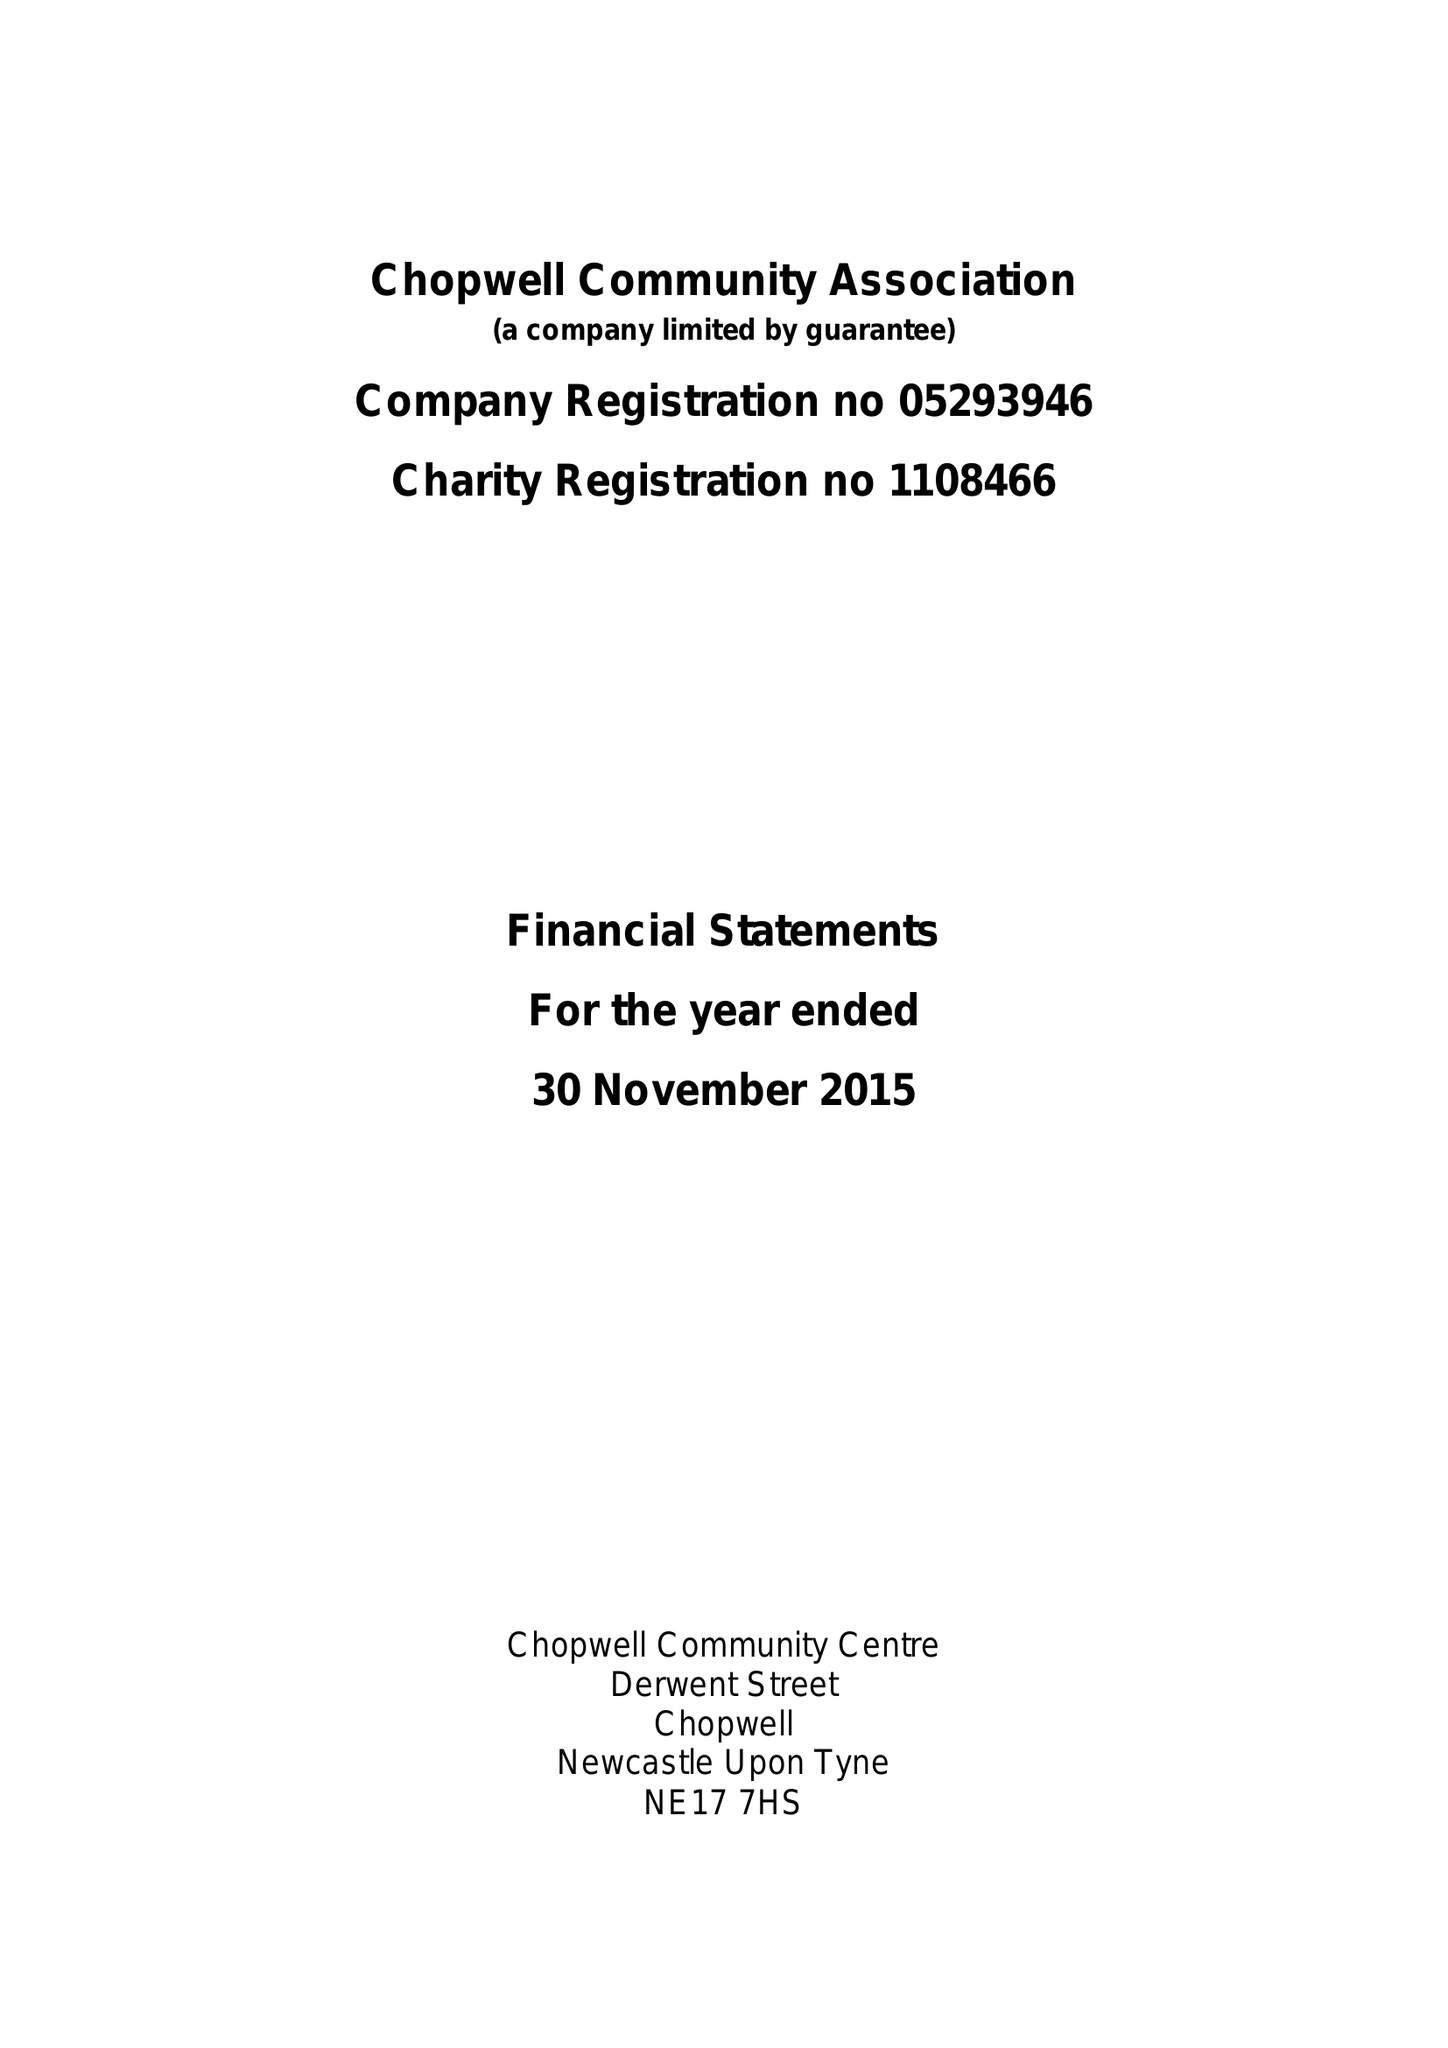What is the value for the charity_number?
Answer the question using a single word or phrase. 1108466 